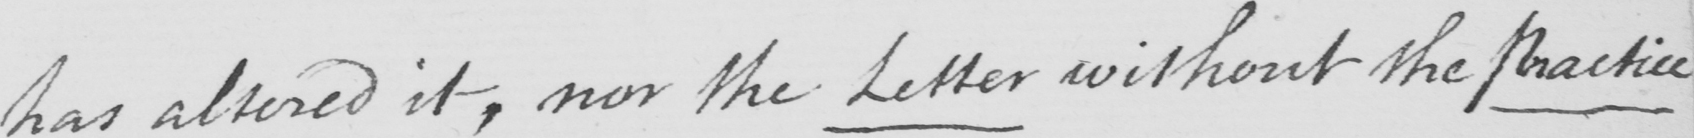What does this handwritten line say? has altered it , nor the Letter without the Practice 